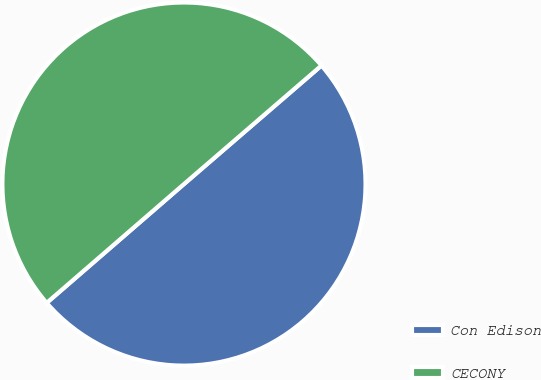<chart> <loc_0><loc_0><loc_500><loc_500><pie_chart><fcel>Con Edison<fcel>CECONY<nl><fcel>49.97%<fcel>50.03%<nl></chart> 